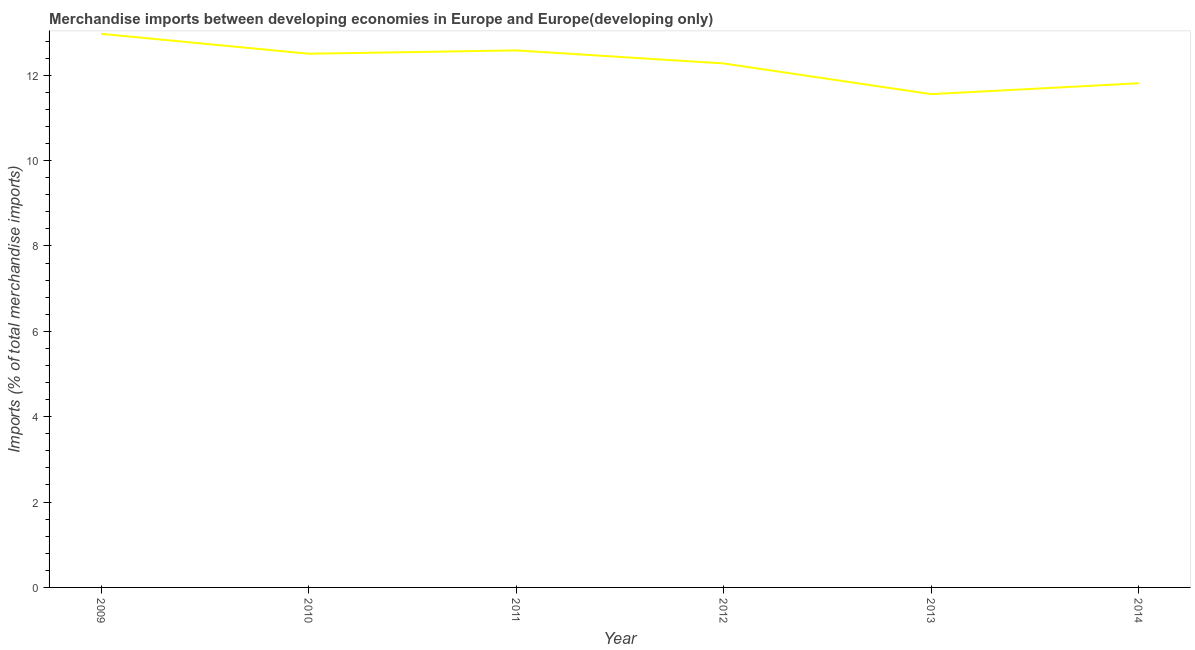What is the merchandise imports in 2010?
Offer a terse response. 12.5. Across all years, what is the maximum merchandise imports?
Keep it short and to the point. 12.97. Across all years, what is the minimum merchandise imports?
Offer a terse response. 11.56. What is the sum of the merchandise imports?
Keep it short and to the point. 73.69. What is the difference between the merchandise imports in 2010 and 2014?
Provide a short and direct response. 0.69. What is the average merchandise imports per year?
Provide a short and direct response. 12.28. What is the median merchandise imports?
Your answer should be compact. 12.39. In how many years, is the merchandise imports greater than 6.8 %?
Offer a terse response. 6. What is the ratio of the merchandise imports in 2009 to that in 2014?
Your answer should be compact. 1.1. Is the merchandise imports in 2010 less than that in 2014?
Your response must be concise. No. Is the difference between the merchandise imports in 2010 and 2011 greater than the difference between any two years?
Offer a very short reply. No. What is the difference between the highest and the second highest merchandise imports?
Keep it short and to the point. 0.39. Is the sum of the merchandise imports in 2010 and 2013 greater than the maximum merchandise imports across all years?
Offer a very short reply. Yes. What is the difference between the highest and the lowest merchandise imports?
Offer a terse response. 1.41. In how many years, is the merchandise imports greater than the average merchandise imports taken over all years?
Your answer should be very brief. 3. Does the merchandise imports monotonically increase over the years?
Provide a short and direct response. No. What is the difference between two consecutive major ticks on the Y-axis?
Provide a succinct answer. 2. Are the values on the major ticks of Y-axis written in scientific E-notation?
Ensure brevity in your answer.  No. Does the graph contain any zero values?
Make the answer very short. No. What is the title of the graph?
Give a very brief answer. Merchandise imports between developing economies in Europe and Europe(developing only). What is the label or title of the Y-axis?
Ensure brevity in your answer.  Imports (% of total merchandise imports). What is the Imports (% of total merchandise imports) in 2009?
Provide a short and direct response. 12.97. What is the Imports (% of total merchandise imports) in 2010?
Your response must be concise. 12.5. What is the Imports (% of total merchandise imports) in 2011?
Keep it short and to the point. 12.58. What is the Imports (% of total merchandise imports) of 2012?
Your answer should be very brief. 12.27. What is the Imports (% of total merchandise imports) in 2013?
Your response must be concise. 11.56. What is the Imports (% of total merchandise imports) of 2014?
Offer a terse response. 11.81. What is the difference between the Imports (% of total merchandise imports) in 2009 and 2010?
Provide a short and direct response. 0.47. What is the difference between the Imports (% of total merchandise imports) in 2009 and 2011?
Offer a terse response. 0.39. What is the difference between the Imports (% of total merchandise imports) in 2009 and 2012?
Offer a very short reply. 0.69. What is the difference between the Imports (% of total merchandise imports) in 2009 and 2013?
Your answer should be compact. 1.41. What is the difference between the Imports (% of total merchandise imports) in 2009 and 2014?
Your answer should be very brief. 1.16. What is the difference between the Imports (% of total merchandise imports) in 2010 and 2011?
Offer a terse response. -0.08. What is the difference between the Imports (% of total merchandise imports) in 2010 and 2012?
Your response must be concise. 0.23. What is the difference between the Imports (% of total merchandise imports) in 2010 and 2013?
Provide a succinct answer. 0.95. What is the difference between the Imports (% of total merchandise imports) in 2010 and 2014?
Keep it short and to the point. 0.69. What is the difference between the Imports (% of total merchandise imports) in 2011 and 2012?
Your answer should be compact. 0.31. What is the difference between the Imports (% of total merchandise imports) in 2011 and 2013?
Offer a terse response. 1.02. What is the difference between the Imports (% of total merchandise imports) in 2011 and 2014?
Your response must be concise. 0.77. What is the difference between the Imports (% of total merchandise imports) in 2012 and 2013?
Give a very brief answer. 0.72. What is the difference between the Imports (% of total merchandise imports) in 2012 and 2014?
Make the answer very short. 0.46. What is the difference between the Imports (% of total merchandise imports) in 2013 and 2014?
Your answer should be compact. -0.25. What is the ratio of the Imports (% of total merchandise imports) in 2009 to that in 2011?
Offer a very short reply. 1.03. What is the ratio of the Imports (% of total merchandise imports) in 2009 to that in 2012?
Make the answer very short. 1.06. What is the ratio of the Imports (% of total merchandise imports) in 2009 to that in 2013?
Offer a terse response. 1.12. What is the ratio of the Imports (% of total merchandise imports) in 2009 to that in 2014?
Make the answer very short. 1.1. What is the ratio of the Imports (% of total merchandise imports) in 2010 to that in 2011?
Offer a very short reply. 0.99. What is the ratio of the Imports (% of total merchandise imports) in 2010 to that in 2013?
Offer a very short reply. 1.08. What is the ratio of the Imports (% of total merchandise imports) in 2010 to that in 2014?
Ensure brevity in your answer.  1.06. What is the ratio of the Imports (% of total merchandise imports) in 2011 to that in 2013?
Your answer should be very brief. 1.09. What is the ratio of the Imports (% of total merchandise imports) in 2011 to that in 2014?
Make the answer very short. 1.06. What is the ratio of the Imports (% of total merchandise imports) in 2012 to that in 2013?
Your answer should be very brief. 1.06. What is the ratio of the Imports (% of total merchandise imports) in 2012 to that in 2014?
Offer a very short reply. 1.04. 